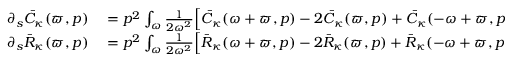<formula> <loc_0><loc_0><loc_500><loc_500>\begin{array} { r l } { \partial _ { s } \bar { C } _ { \kappa } ( \varpi , p ) } & = p ^ { 2 } \int _ { \omega } \frac { 1 } { 2 \omega ^ { 2 } } \left [ \bar { C } _ { \kappa } ( \omega + \varpi , p ) - 2 \bar { C } _ { \kappa } ( \varpi , p ) + \bar { C } _ { \kappa } ( - \omega + \varpi , p ) \right ] \tilde { \partial } _ { s } \int _ { q } \bar { C } _ { \kappa } ( \omega , q ) } \\ { \partial _ { s } \bar { R } _ { \kappa } ( \varpi , p ) } & = p ^ { 2 } \int _ { \omega } \frac { 1 } { 2 \omega ^ { 2 } } \left [ \bar { R } _ { \kappa } ( \omega + \varpi , p ) - 2 \bar { R } _ { \kappa } ( \varpi , p ) + \bar { R } _ { \kappa } ( - \omega + \varpi , p ) \right ] \tilde { \partial } _ { s } \int _ { q } \bar { C } _ { \kappa } ( \omega , q ) \, . } \end{array}</formula> 